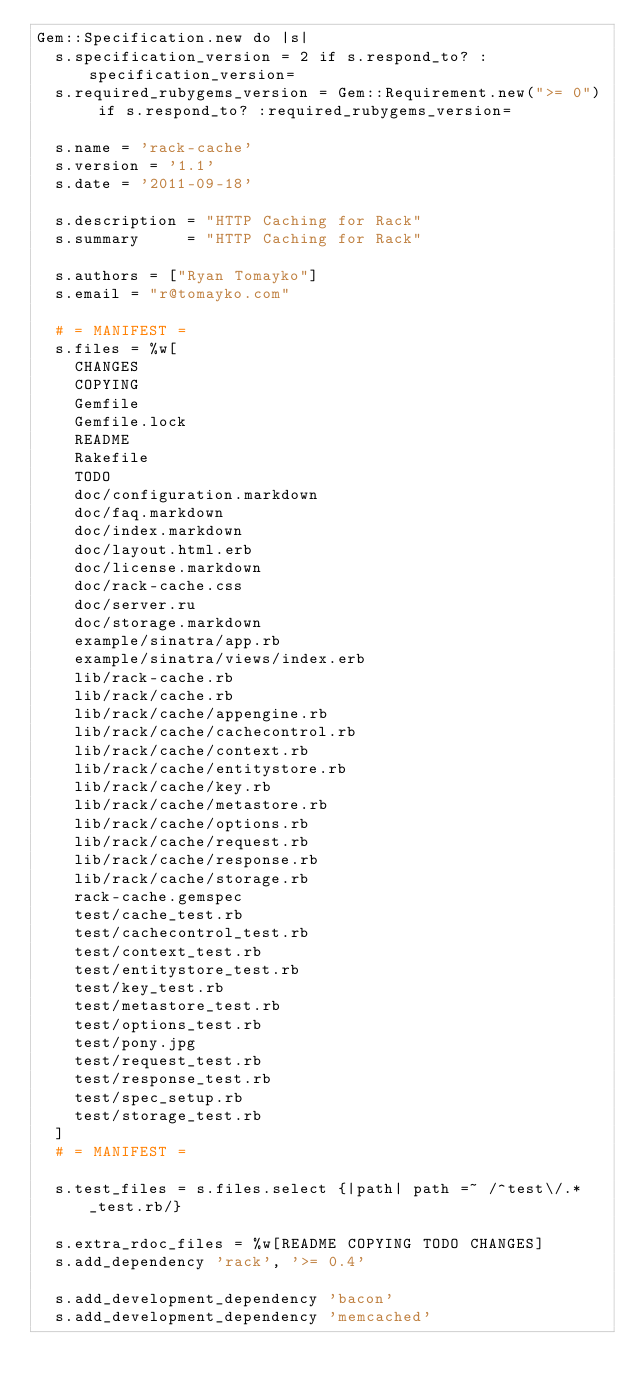Convert code to text. <code><loc_0><loc_0><loc_500><loc_500><_Ruby_>Gem::Specification.new do |s|
  s.specification_version = 2 if s.respond_to? :specification_version=
  s.required_rubygems_version = Gem::Requirement.new(">= 0") if s.respond_to? :required_rubygems_version=

  s.name = 'rack-cache'
  s.version = '1.1'
  s.date = '2011-09-18'

  s.description = "HTTP Caching for Rack"
  s.summary     = "HTTP Caching for Rack"

  s.authors = ["Ryan Tomayko"]
  s.email = "r@tomayko.com"

  # = MANIFEST =
  s.files = %w[
    CHANGES
    COPYING
    Gemfile
    Gemfile.lock
    README
    Rakefile
    TODO
    doc/configuration.markdown
    doc/faq.markdown
    doc/index.markdown
    doc/layout.html.erb
    doc/license.markdown
    doc/rack-cache.css
    doc/server.ru
    doc/storage.markdown
    example/sinatra/app.rb
    example/sinatra/views/index.erb
    lib/rack-cache.rb
    lib/rack/cache.rb
    lib/rack/cache/appengine.rb
    lib/rack/cache/cachecontrol.rb
    lib/rack/cache/context.rb
    lib/rack/cache/entitystore.rb
    lib/rack/cache/key.rb
    lib/rack/cache/metastore.rb
    lib/rack/cache/options.rb
    lib/rack/cache/request.rb
    lib/rack/cache/response.rb
    lib/rack/cache/storage.rb
    rack-cache.gemspec
    test/cache_test.rb
    test/cachecontrol_test.rb
    test/context_test.rb
    test/entitystore_test.rb
    test/key_test.rb
    test/metastore_test.rb
    test/options_test.rb
    test/pony.jpg
    test/request_test.rb
    test/response_test.rb
    test/spec_setup.rb
    test/storage_test.rb
  ]
  # = MANIFEST =

  s.test_files = s.files.select {|path| path =~ /^test\/.*_test.rb/}

  s.extra_rdoc_files = %w[README COPYING TODO CHANGES]
  s.add_dependency 'rack', '>= 0.4'

  s.add_development_dependency 'bacon'
  s.add_development_dependency 'memcached'</code> 